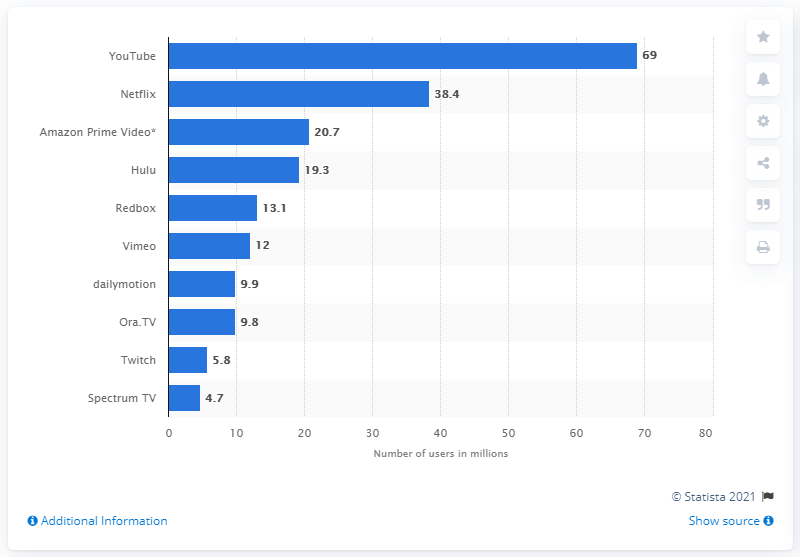Draw attention to some important aspects in this diagram. As of July 2018, YouTube had 69 million mobile users. According to data, 38.4% of U.S. users access Netflix via mobile. According to data collected as of July 2018, YouTube was the most popular video streaming service in the United States. 